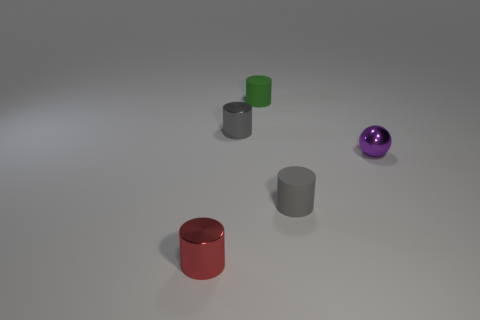What number of cubes are brown metallic things or tiny matte objects? In the image, there are no brown metallic cubes or tiny matte objects. The objects presented are a red cylinder, a green cube, two grey cylinders of different sizes, and a purple, shiny sphere. 